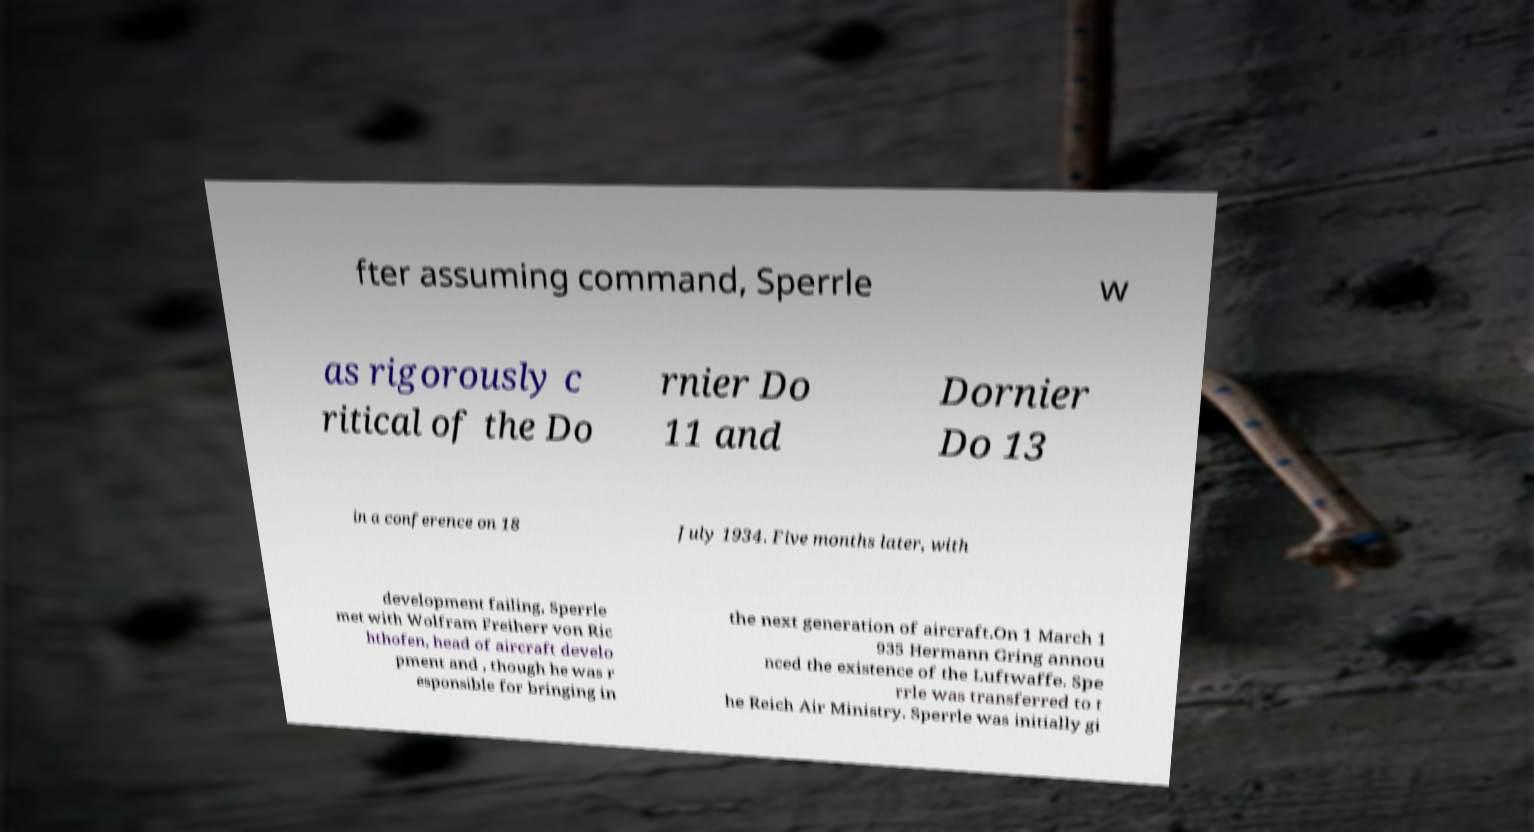There's text embedded in this image that I need extracted. Can you transcribe it verbatim? fter assuming command, Sperrle w as rigorously c ritical of the Do rnier Do 11 and Dornier Do 13 in a conference on 18 July 1934. Five months later, with development failing, Sperrle met with Wolfram Freiherr von Ric hthofen, head of aircraft develo pment and , though he was r esponsible for bringing in the next generation of aircraft.On 1 March 1 935 Hermann Gring annou nced the existence of the Luftwaffe. Spe rrle was transferred to t he Reich Air Ministry. Sperrle was initially gi 